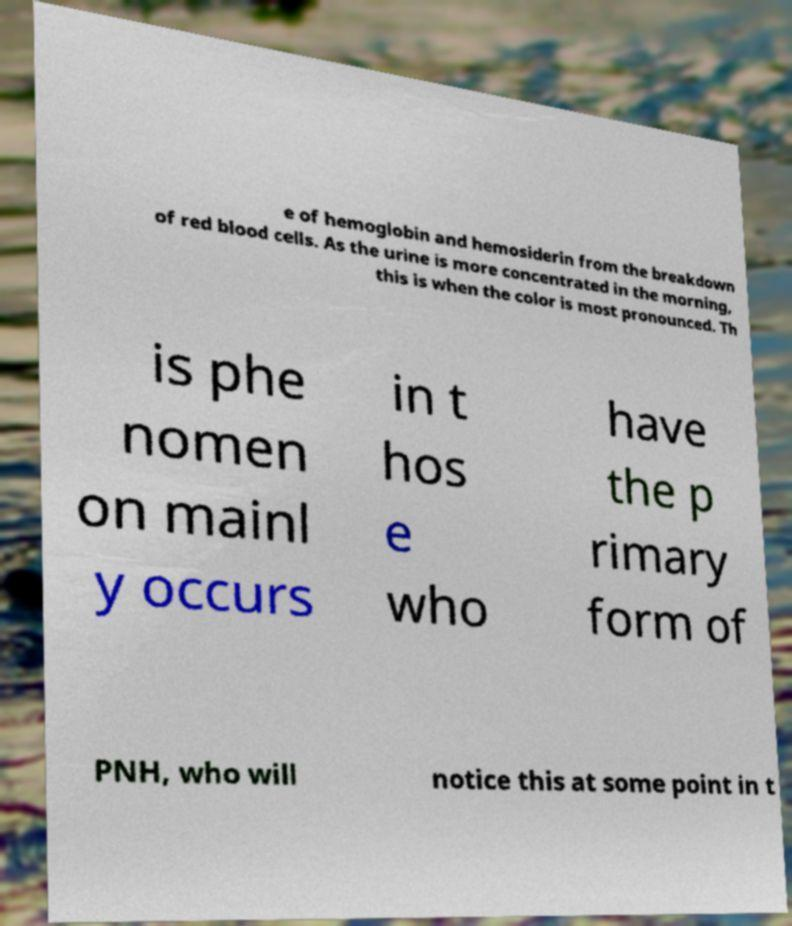Could you assist in decoding the text presented in this image and type it out clearly? e of hemoglobin and hemosiderin from the breakdown of red blood cells. As the urine is more concentrated in the morning, this is when the color is most pronounced. Th is phe nomen on mainl y occurs in t hos e who have the p rimary form of PNH, who will notice this at some point in t 